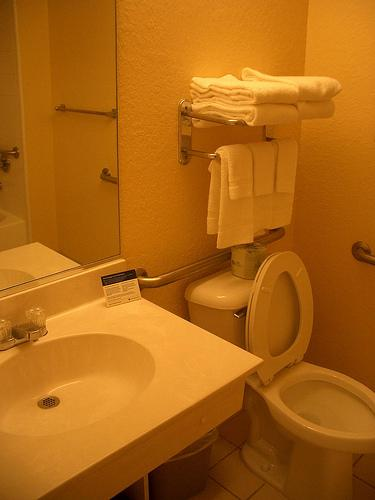What two objects are located to the left and right sides of the bathroom? On the left, there is a white sink, while on the right side is a white toilet. If you were to create a multiple-choice question about this image, what would the question and the correct answer be? C) Towel handle List three items that can be found hanging or resting on other items in this bathroom. Toilet paper roll on tank of toilet, towels draped over a handle, and white towels stacked on a shelf. Identify the type of room depicted in the image. The image shows a bathroom. For a referential expression grounding task, connect a descriptor with one object in the scene. The "clean white toilet" refers to the toilet on the right side of the bathroom with seat and lid up. What object has a sign on it in the image? There is a sign on a sink. Imagine an advertisement for this bathroom. What would be the main selling point based on the image? "Experience ultimate comfort and cleanliness in our pristine white bathroom, complete with luxuriously soft towels and modern amenities for a truly rejuvenating experience." What is the state and color of the towels hanging in the bathroom? The towels hanging are white and folded neatly over a handle. Describe the position of the toilet seat and lid in the image. The toilet seat and lid are both raised up. Using a poetic style, describe the appearance of the bathroom floor. Upon the bathroom floor, a delicate dance of tiles creates a mesmerizing pattern, weaving their tale of elegance and practicality. 